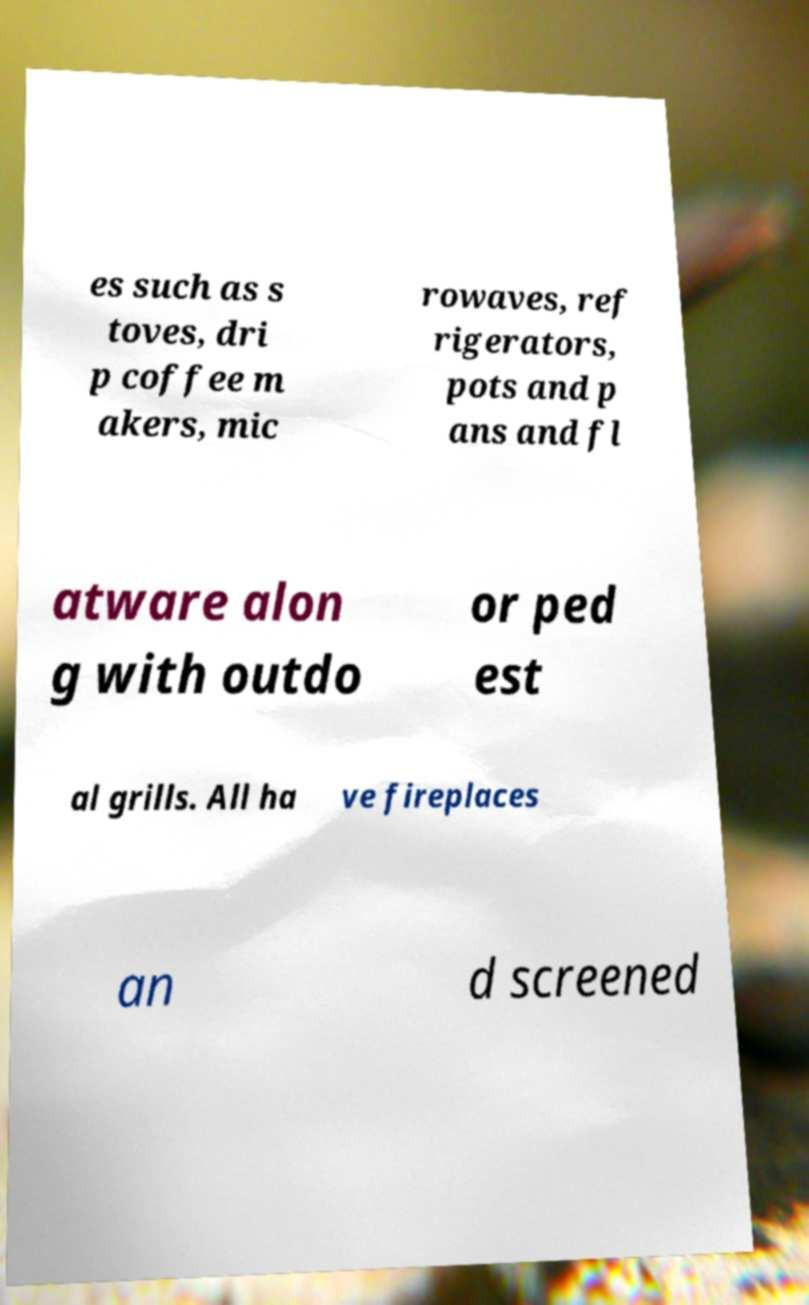There's text embedded in this image that I need extracted. Can you transcribe it verbatim? es such as s toves, dri p coffee m akers, mic rowaves, ref rigerators, pots and p ans and fl atware alon g with outdo or ped est al grills. All ha ve fireplaces an d screened 